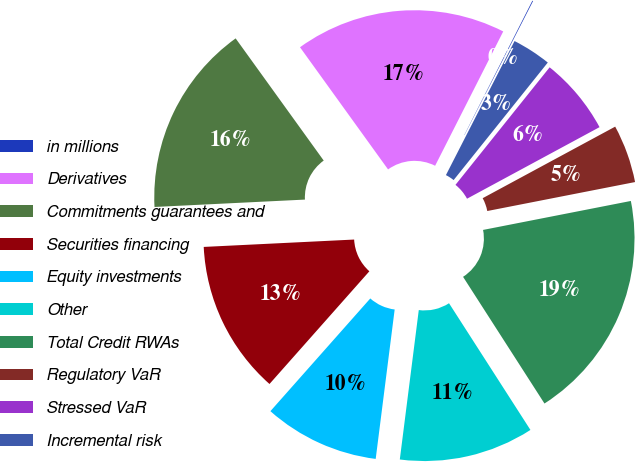<chart> <loc_0><loc_0><loc_500><loc_500><pie_chart><fcel>in millions<fcel>Derivatives<fcel>Commitments guarantees and<fcel>Securities financing<fcel>Equity investments<fcel>Other<fcel>Total Credit RWAs<fcel>Regulatory VaR<fcel>Stressed VaR<fcel>Incremental risk<nl><fcel>0.06%<fcel>17.41%<fcel>15.84%<fcel>12.68%<fcel>9.53%<fcel>11.1%<fcel>18.99%<fcel>4.8%<fcel>6.37%<fcel>3.22%<nl></chart> 